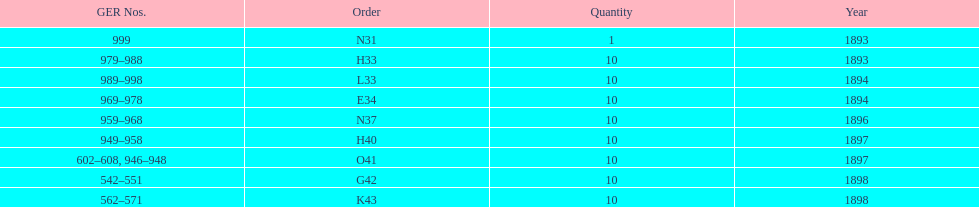Which order was the next order after l33? E34. 